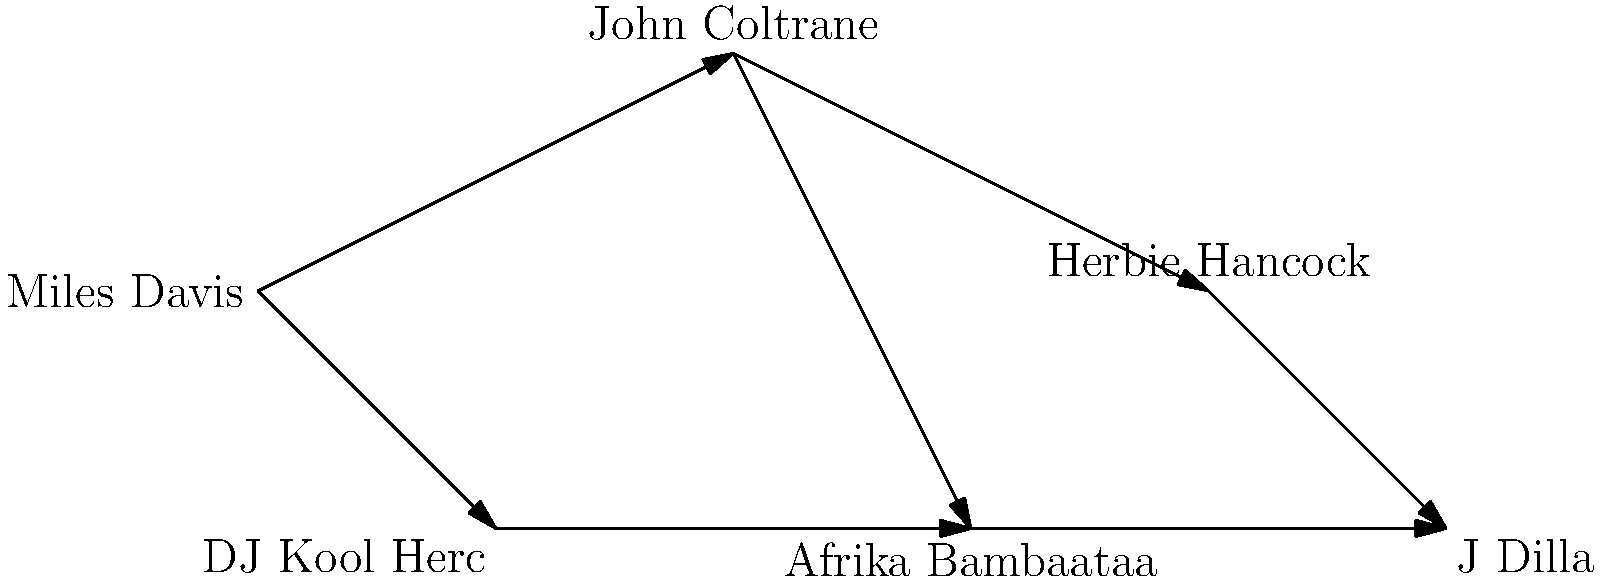Based on the network diagram, which jazz musician appears to have had the most direct influence on early hip-hop pioneers? To answer this question, we need to analyze the network diagram step-by-step:

1. The diagram shows three jazz musicians: Miles Davis, John Coltrane, and Herbie Hancock.
2. It also shows three hip-hop artists/producers: DJ Kool Herc, Afrika Bambaataa, and J Dilla.
3. The arrows indicate the direction of influence.
4. Miles Davis has arrows pointing to both John Coltrane and DJ Kool Herc.
5. John Coltrane has arrows pointing to Herbie Hancock and Afrika Bambaataa.
6. Herbie Hancock has an arrow pointing to J Dilla.
7. There are also connections between the hip-hop artists themselves.

Looking at the direct connections between jazz musicians and hip-hop artists:
- Miles Davis directly influences DJ Kool Herc
- John Coltrane directly influences Afrika Bambaataa
- Herbie Hancock directly influences J Dilla

Among these, Miles Davis stands out because he directly influences DJ Kool Herc, who is widely recognized as one of the earliest pioneers of hip-hop. This direct connection to an early hip-hop figure suggests that Miles Davis had the most direct influence on early hip-hop pioneers according to this diagram.
Answer: Miles Davis 